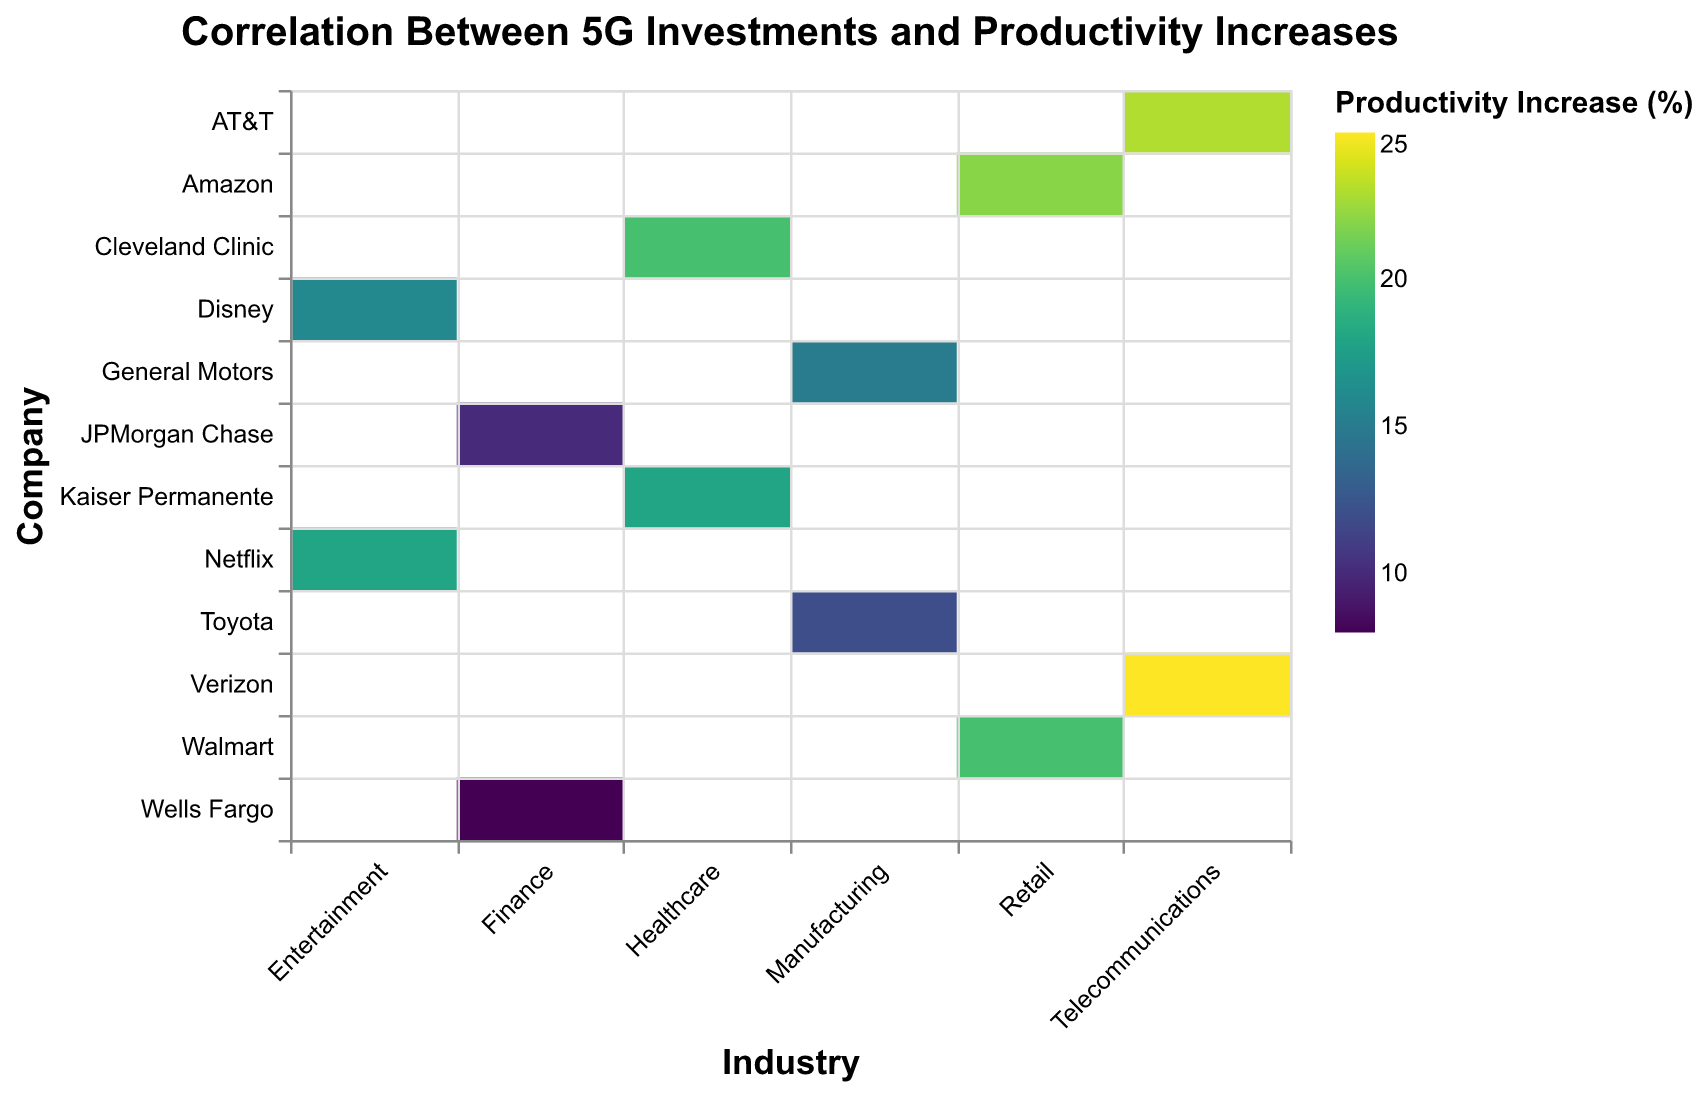What is the title of the heatmap? The title of the heatmap is located at the top center and is usually a brief description of what the heatmap represents. In this case, it reads "Correlation Between 5G Investments and Productivity Increases".
Answer: Correlation Between 5G Investments and Productivity Increases Which industry has the highest productivity increase? By looking at the color scale, we can see which industry has the highest productivity increase by finding the darkest colored cells. The "Telecommunications" industry (Verizon and AT&T) shows the highest productivity increases with 25% and 23% respectively.
Answer: Telecommunications What is the highest productivity increase (%) shown in the heatmap? Identify the darkest color on the heatmap, which represents the highest value. The tooltip also provides exact values when hovering over specific cells. Here, Verizon in the Telecommunications industry has the highest productivity increase at 25%.
Answer: 25% Which company in the Finance industry invested the most in 5G infrastructure? Look for the companies listed under the Finance industry and compare the tooltip values for their 5G infrastructure investments. JPMorgan Chase invested the most with 400 million USD.
Answer: JPMorgan Chase Compare the productivity increases between Walmart and Amazon. Which company had a higher increase? Check both Walmart and Amazon rows, which are under the Retail industry column. Amazon recorded a higher productivity increase with 22%, compared to Walmart's 20%.
Answer: Amazon Calculate the average productivity increase across all companies in the Healthcare industry. Sum the productivity increases of Kaiser Permanente (18%) and Cleveland Clinic (20%), then divide by the number of companies (2). (18 + 20) / 2 = 19%
Answer: 19% Which company in the Entertainment industry had a higher productivity increase? Compare the rows in the Entertainment industry. Netflix has a productivity increase of 18%, whereas Disney has 16%. Thus, Netflix had a higher increase.
Answer: Netflix How does the 5G infrastructure investment of Toyota compare to that of AT&T? Look for Toyota in the Manufacturing industry and AT&T in the Telecommunications industry. Toyota invested 500 million USD, while AT&T invested the same amount. Therefore, they invested equally.
Answer: Equal What is the difference in productivity increase percentage between General Motors and Wells Fargo? Locate the values for General Motors (15%) in the Manufacturing industry and Wells Fargo (8%) in the Finance industry. The difference is 15% - 8% = 7%.
Answer: 7% Identify the industry with the maximum variance in productivity increases. Look at the productivity increases within each industry and calculate the variance. The Telecommunications industry ranges from 23% to 25%, giving a variance of 2%. However, the Manufacturing industry ranges only between 12% and 15%, a variance of 3%. Hence, Healthcare has a variance of 2%. Therefore, the Telecommunications industry has one of the highest variances in productivity increase percentage.
Answer: Telecommunications 